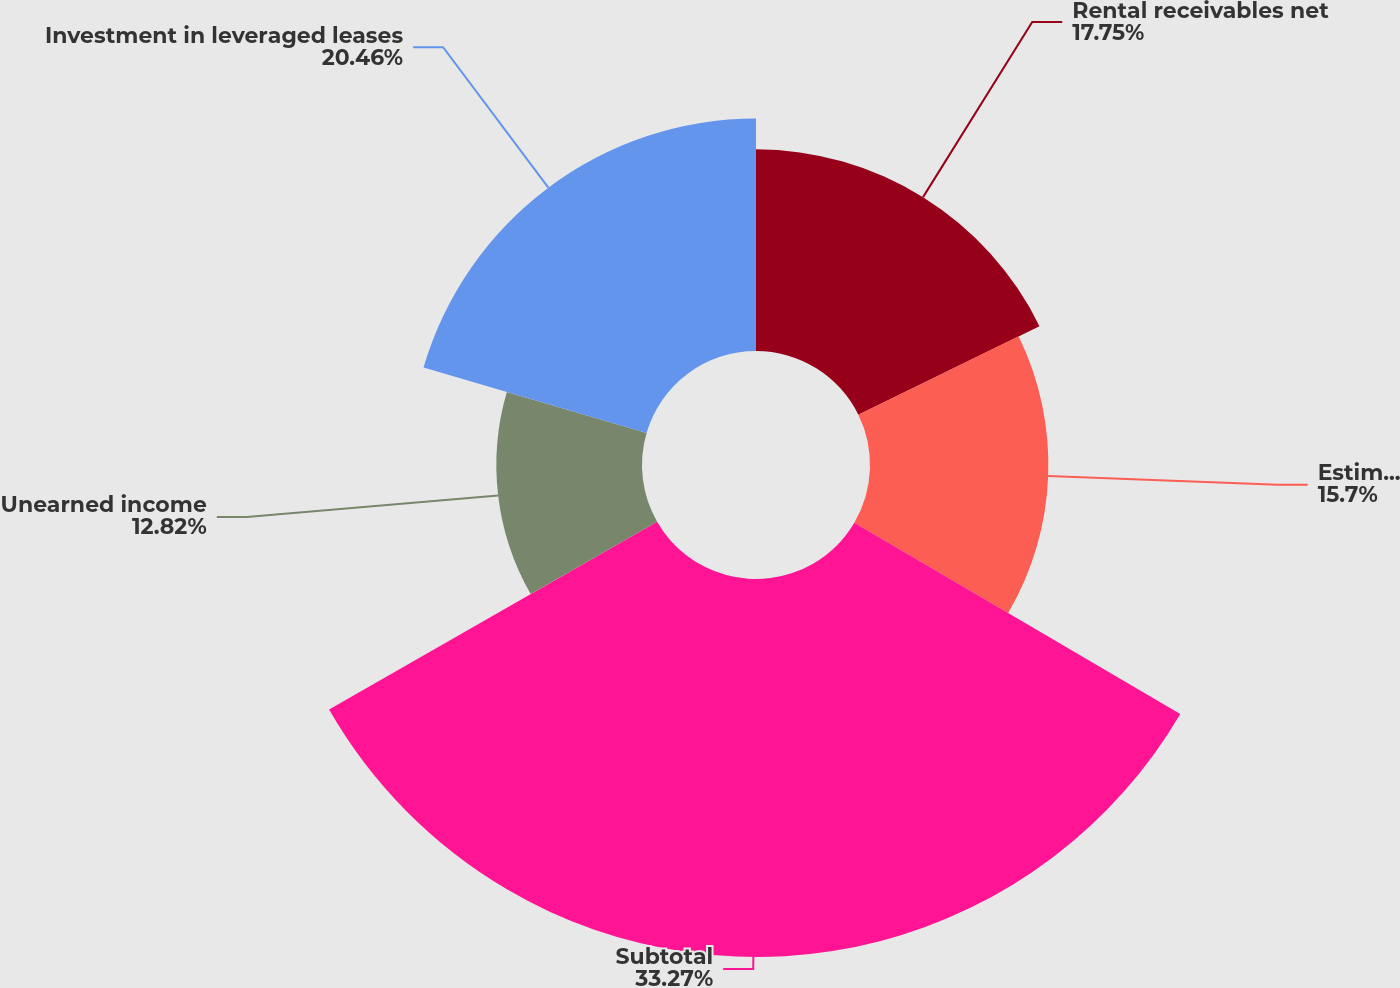<chart> <loc_0><loc_0><loc_500><loc_500><pie_chart><fcel>Rental receivables net<fcel>Estimated residual values<fcel>Subtotal<fcel>Unearned income<fcel>Investment in leveraged leases<nl><fcel>17.75%<fcel>15.7%<fcel>33.27%<fcel>12.82%<fcel>20.46%<nl></chart> 